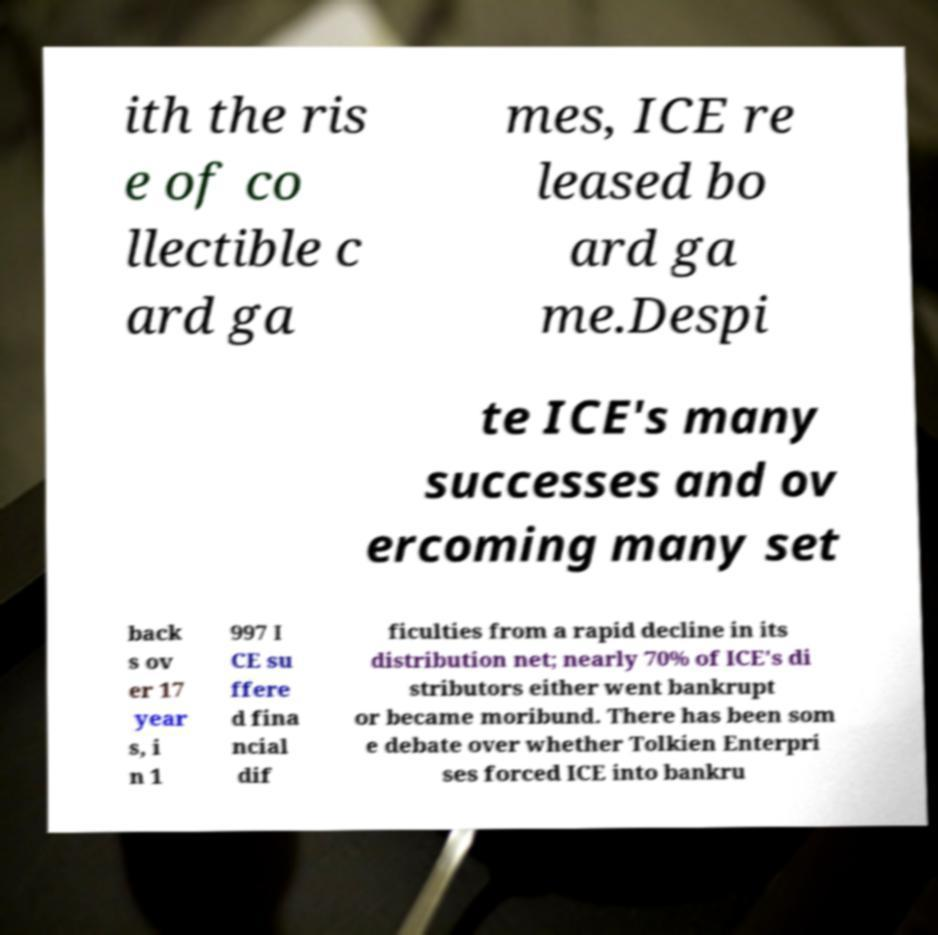What messages or text are displayed in this image? I need them in a readable, typed format. ith the ris e of co llectible c ard ga mes, ICE re leased bo ard ga me.Despi te ICE's many successes and ov ercoming many set back s ov er 17 year s, i n 1 997 I CE su ffere d fina ncial dif ficulties from a rapid decline in its distribution net; nearly 70% of ICE's di stributors either went bankrupt or became moribund. There has been som e debate over whether Tolkien Enterpri ses forced ICE into bankru 